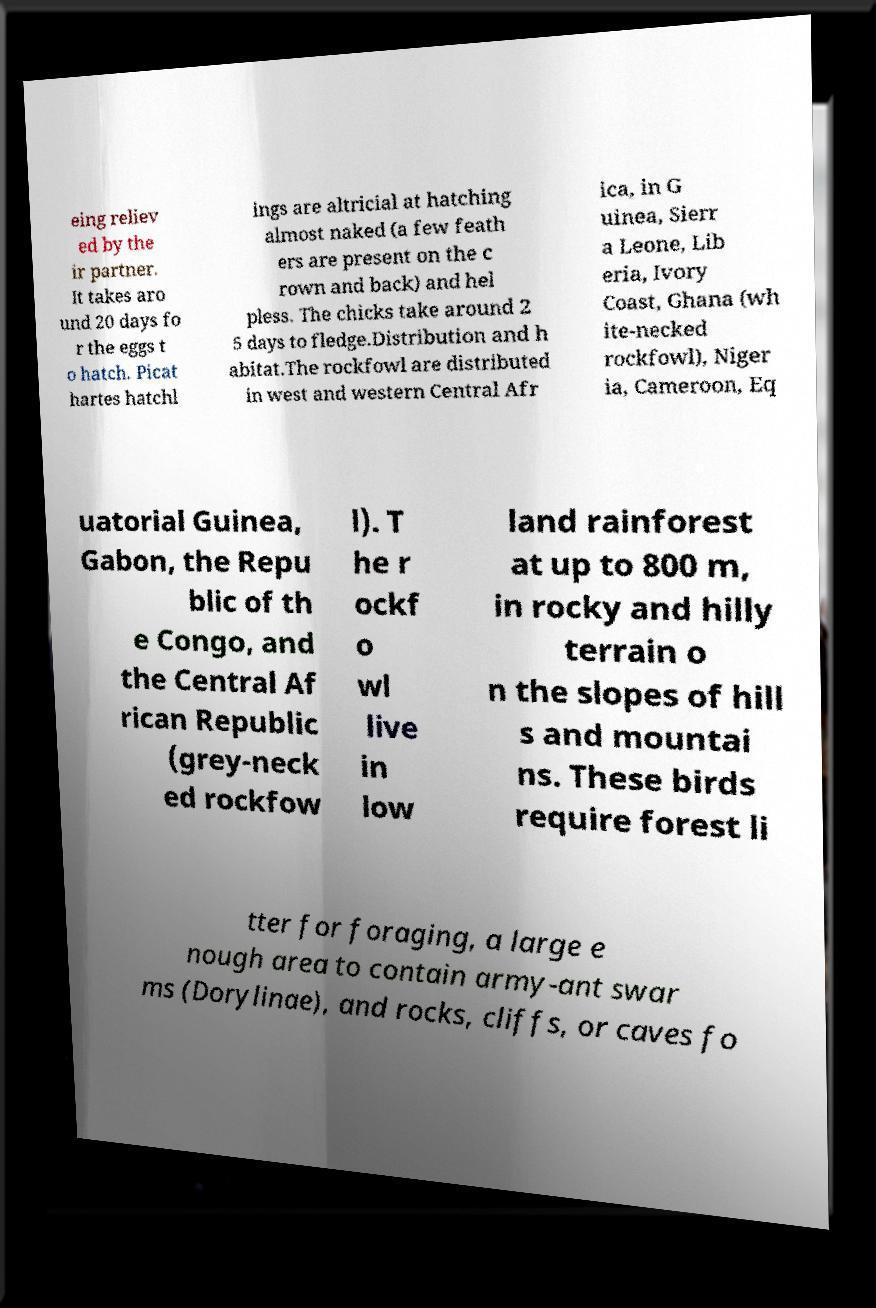What messages or text are displayed in this image? I need them in a readable, typed format. eing reliev ed by the ir partner. It takes aro und 20 days fo r the eggs t o hatch. Picat hartes hatchl ings are altricial at hatching almost naked (a few feath ers are present on the c rown and back) and hel pless. The chicks take around 2 5 days to fledge.Distribution and h abitat.The rockfowl are distributed in west and western Central Afr ica, in G uinea, Sierr a Leone, Lib eria, Ivory Coast, Ghana (wh ite-necked rockfowl), Niger ia, Cameroon, Eq uatorial Guinea, Gabon, the Repu blic of th e Congo, and the Central Af rican Republic (grey-neck ed rockfow l). T he r ockf o wl live in low land rainforest at up to 800 m, in rocky and hilly terrain o n the slopes of hill s and mountai ns. These birds require forest li tter for foraging, a large e nough area to contain army-ant swar ms (Dorylinae), and rocks, cliffs, or caves fo 